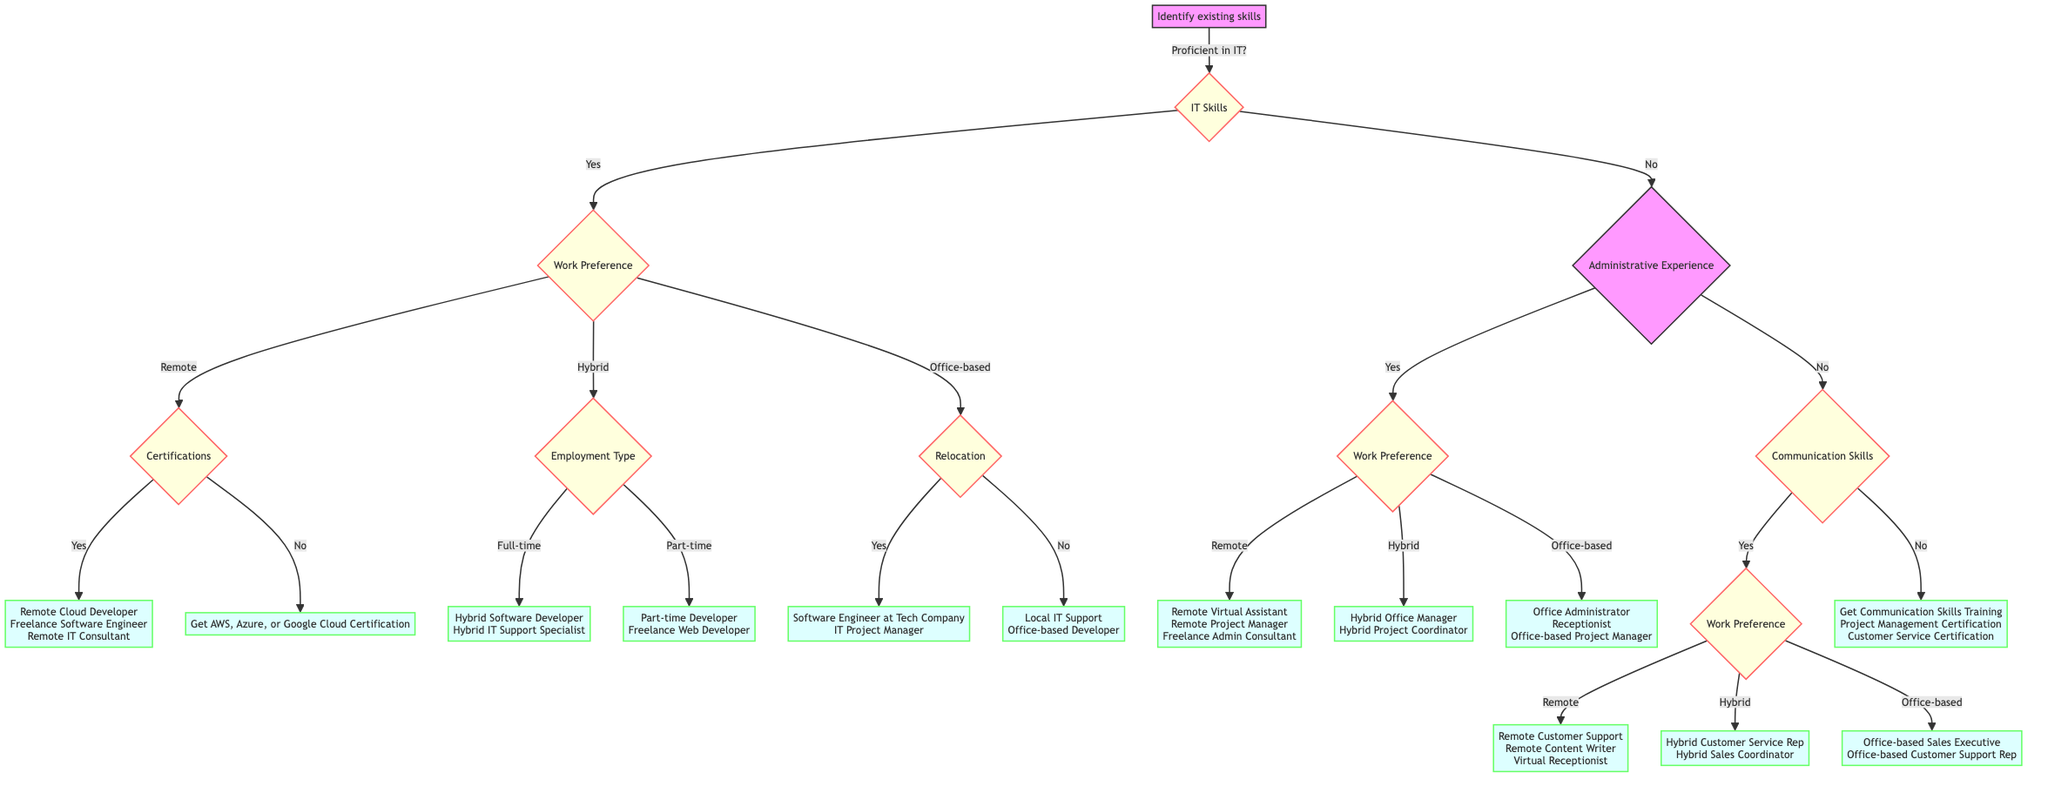What's the initial question in the diagram? The diagram begins with the question "Identify existing skills," which serves as the starting point for determining potential career paths based on skills and preferences.
Answer: Identify existing skills How many career paths are listed for remote work with IT skills and certifications? The diagram shows three career paths for remote work if the individual is proficient in IT and holds relevant certifications: "Remote Cloud Developer," "Freelance Software Engineer," and "Remote IT Consultant."
Answer: Three What happens if you are not proficient in IT and have no administrative experience? If the individual is not proficient in IT and has no administrative experience, they will be directed to the question about their communication and organizational skills. Depending on their response to that question, they might need additional certifications or may explore specific career paths based on communication skills.
Answer: Additional certifications or explore specific career paths What are the career options for someone who prefers hybrid work but is looking for part-time roles? For someone who prefers hybrid work and is looking for part-time roles, the diagram specifies two career paths: "Part-time Developer" and "Freelance Web Developer."
Answer: Part-time Developer, Freelance Web Developer If a person is willing to relocate and has IT skills, what career paths can they pursue? Based on the diagram, if a person is proficient in IT and willing to relocate, they can pursue the following career paths: "Software Engineer at a Tech Company" and "IT Project Manager."
Answer: Software Engineer at a Tech Company, IT Project Manager 